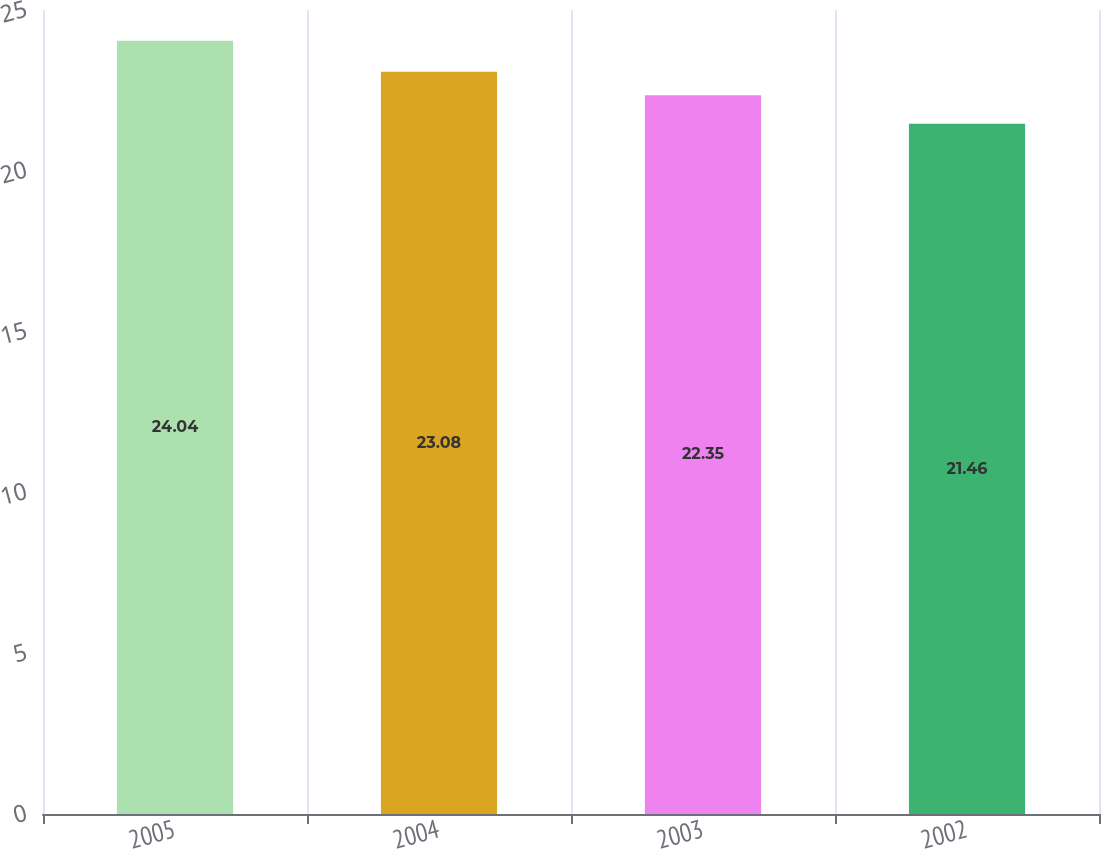<chart> <loc_0><loc_0><loc_500><loc_500><bar_chart><fcel>2005<fcel>2004<fcel>2003<fcel>2002<nl><fcel>24.04<fcel>23.08<fcel>22.35<fcel>21.46<nl></chart> 